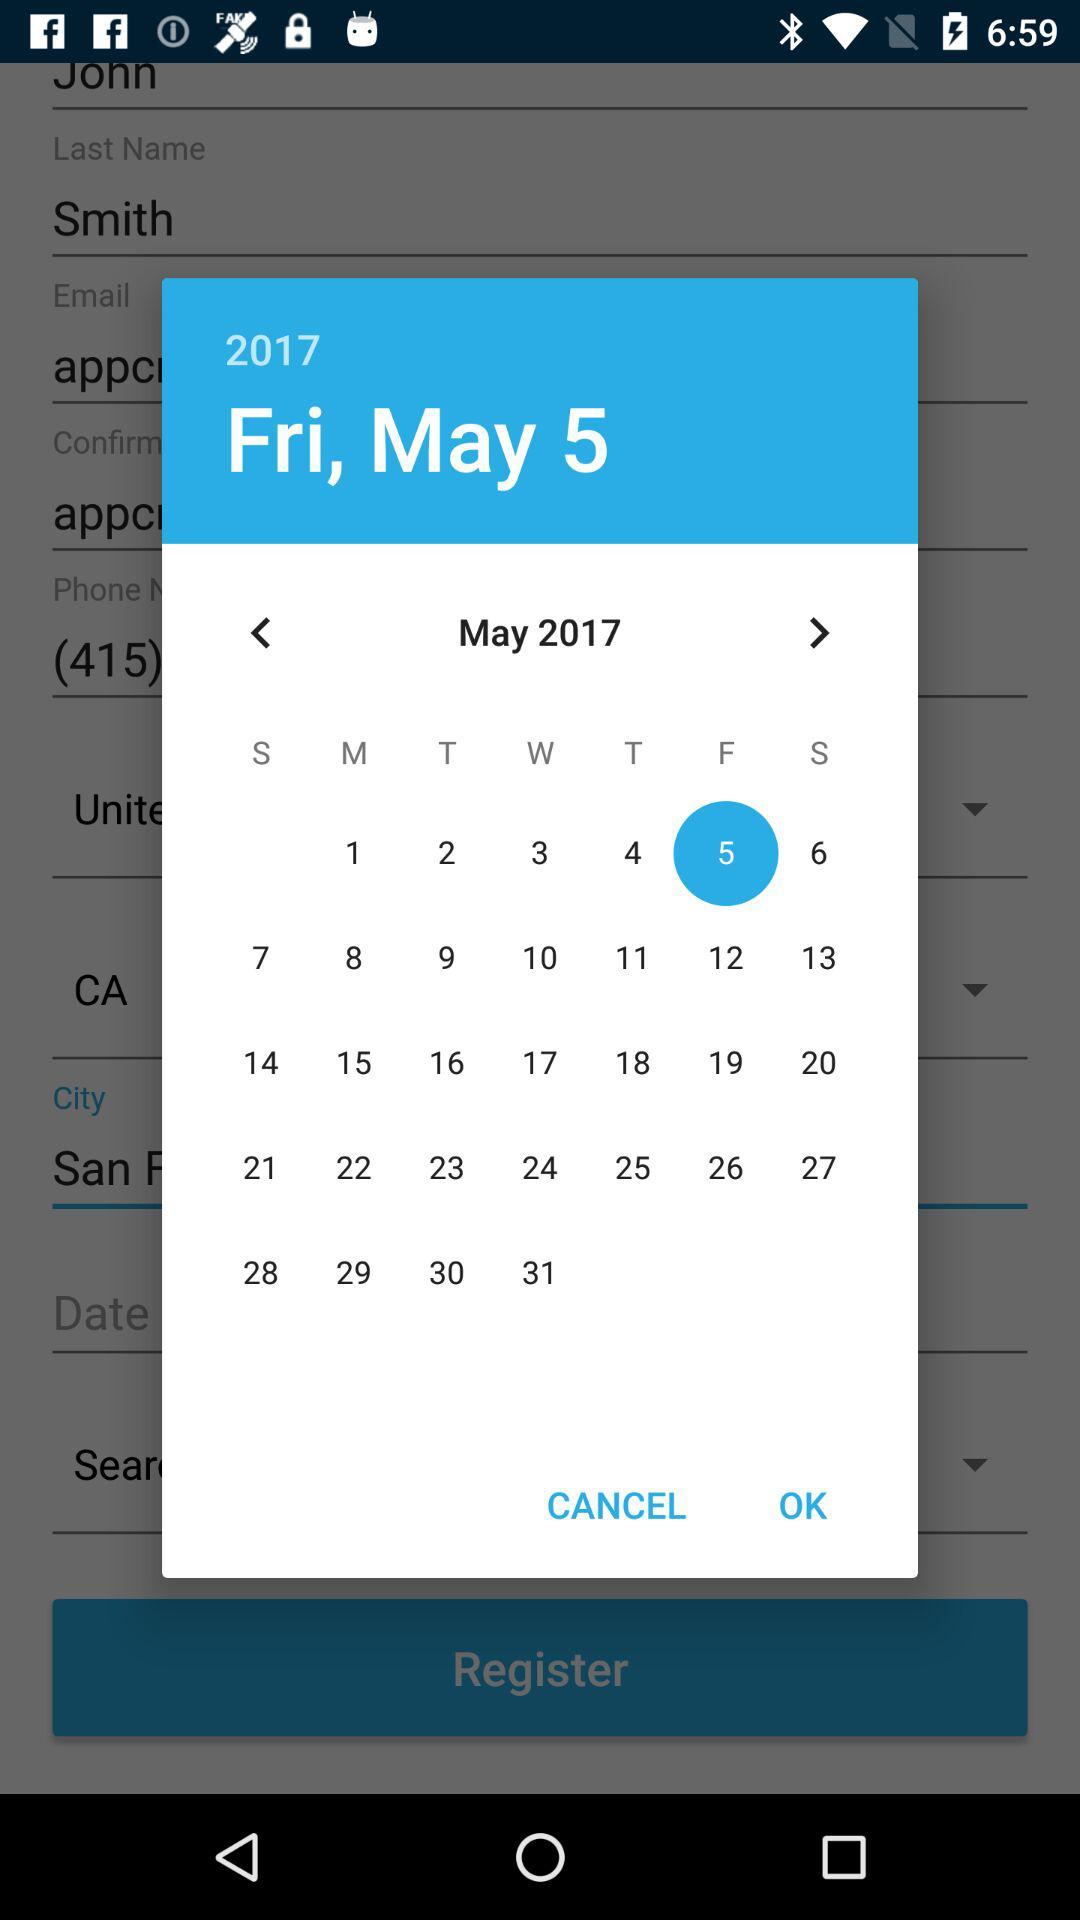What is the day of the selected date? The day is Friday. 